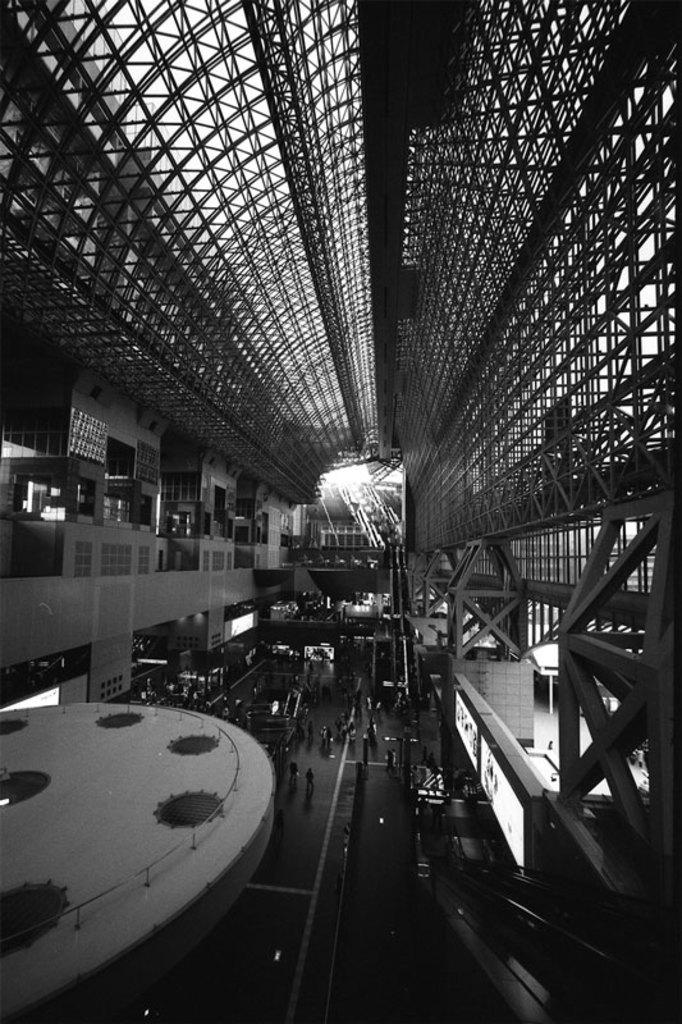What is the color scheme of the image? The image is black and white. What can be seen at the bottom of the image? There are persons standing at the bottom of the image. What is located at the top of the image? There is a roof at the top of the image. What type of nail is being used by the person in the image? There is no nail or person using a nail present in the image. What color is the shirt worn by the person in the image? There is no person or shirt visible in the image, as it is black and white. 